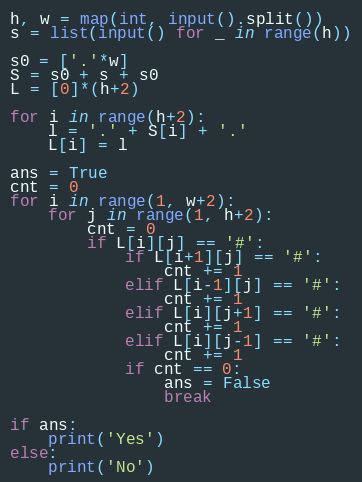Convert code to text. <code><loc_0><loc_0><loc_500><loc_500><_Python_>h, w = map(int, input().split())
s = list(input() for _ in range(h))

s0 = ['.'*w]
S = s0 + s + s0
L = [0]*(h+2)

for i in range(h+2):
    l = '.' + S[i] + '.'
    L[i] = l

ans = True
cnt = 0
for i in range(1, w+2):
    for j in range(1, h+2):
        cnt = 0
        if L[i][j] == '#':
            if L[i+1][j] == '#':
                cnt += 1
            elif L[i-1][j] == '#':
                cnt += 1
            elif L[i][j+1] == '#':
                cnt += 1
            elif L[i][j-1] == '#':
                cnt += 1
            if cnt == 0:
                ans = False
                break

if ans:
    print('Yes')
else:
    print('No')

</code> 